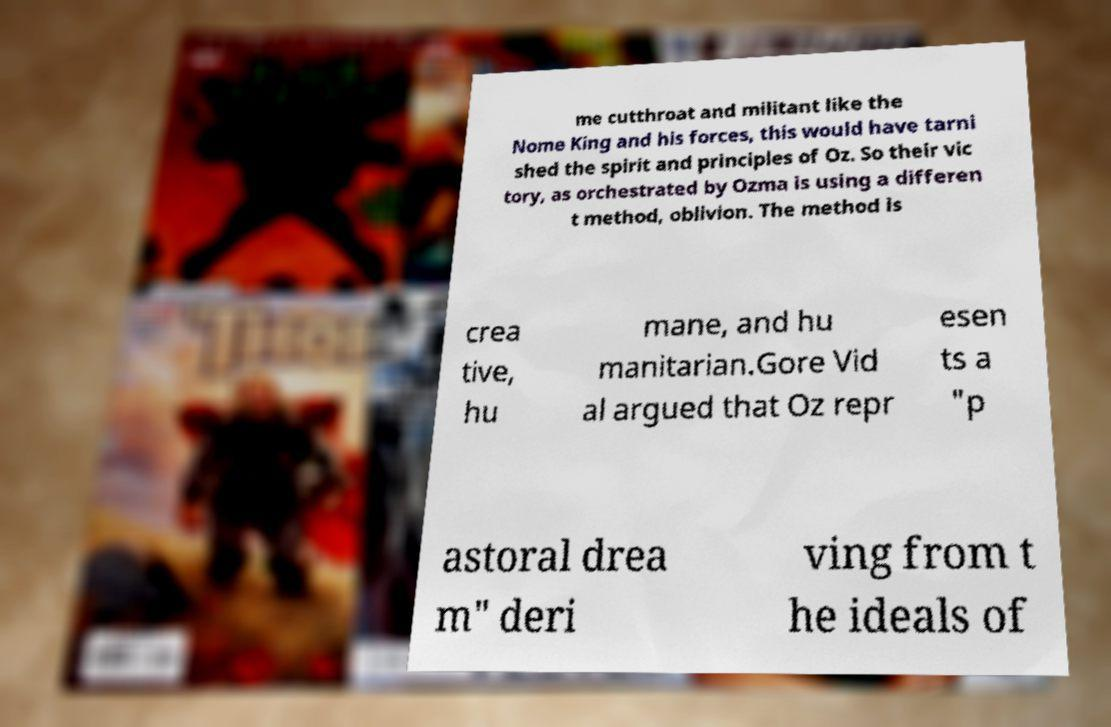Please identify and transcribe the text found in this image. me cutthroat and militant like the Nome King and his forces, this would have tarni shed the spirit and principles of Oz. So their vic tory, as orchestrated by Ozma is using a differen t method, oblivion. The method is crea tive, hu mane, and hu manitarian.Gore Vid al argued that Oz repr esen ts a "p astoral drea m" deri ving from t he ideals of 